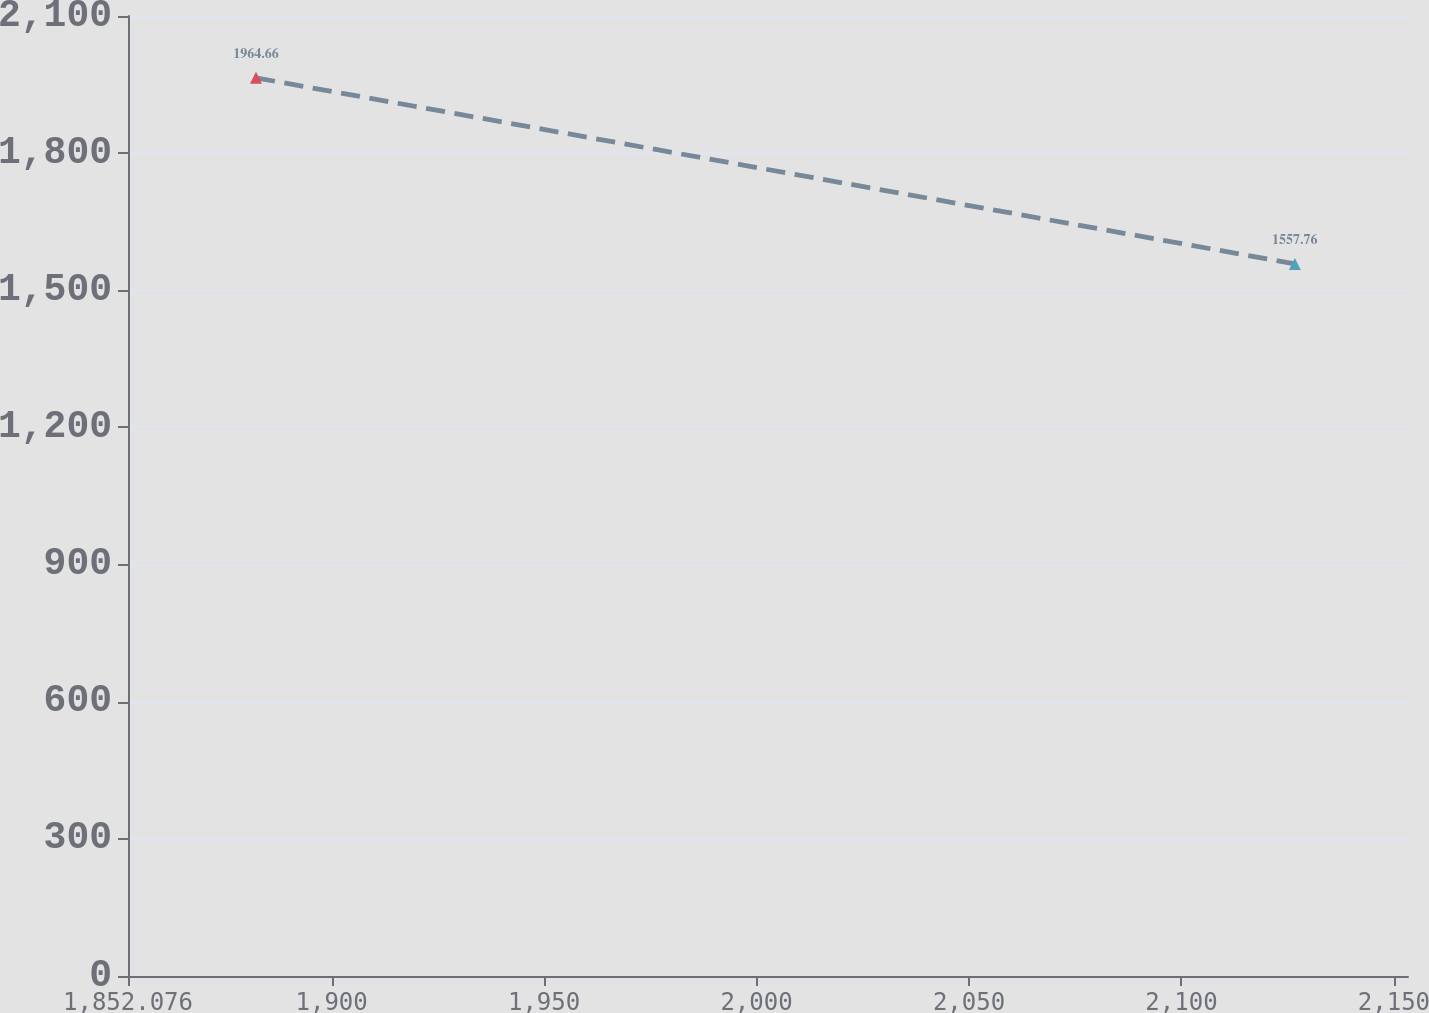<chart> <loc_0><loc_0><loc_500><loc_500><line_chart><ecel><fcel>Unnamed: 1<nl><fcel>1882.2<fcel>1964.66<nl><fcel>2126.69<fcel>1557.76<nl><fcel>2183.44<fcel>1633.1<nl></chart> 